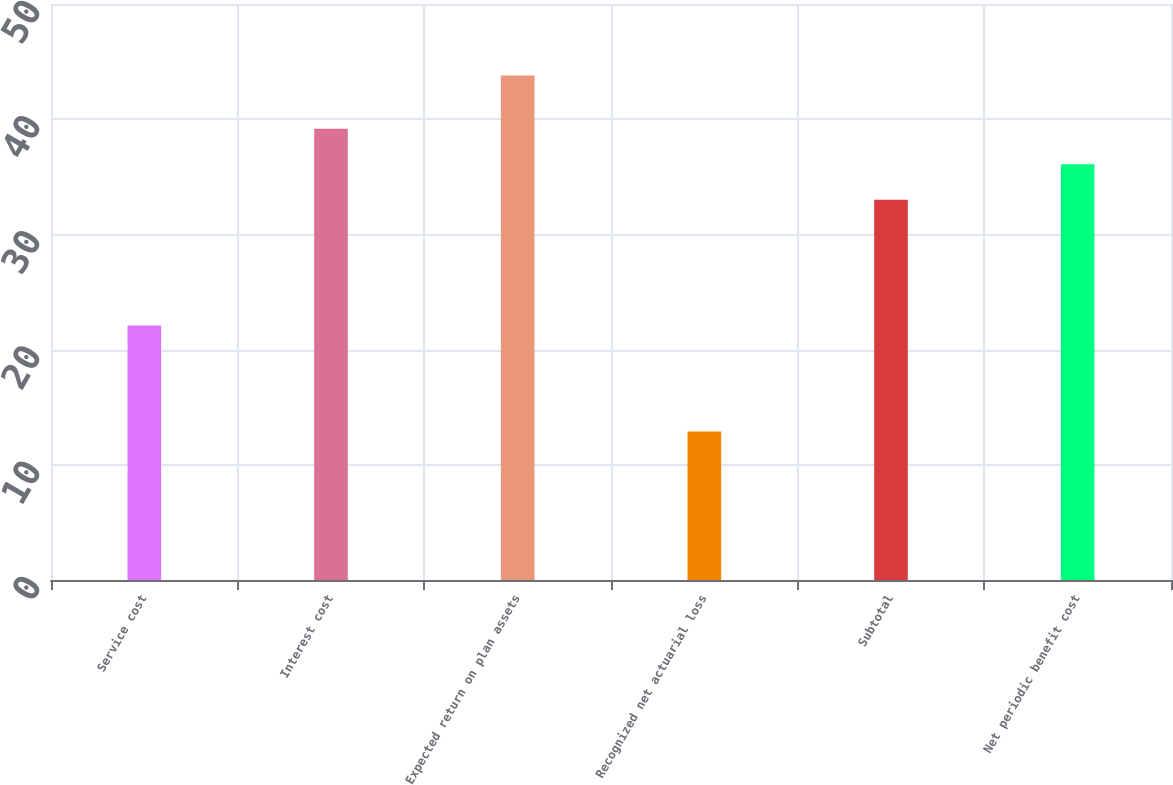<chart> <loc_0><loc_0><loc_500><loc_500><bar_chart><fcel>Service cost<fcel>Interest cost<fcel>Expected return on plan assets<fcel>Recognized net actuarial loss<fcel>Subtotal<fcel>Net periodic benefit cost<nl><fcel>22.1<fcel>39.18<fcel>43.8<fcel>12.9<fcel>33<fcel>36.09<nl></chart> 